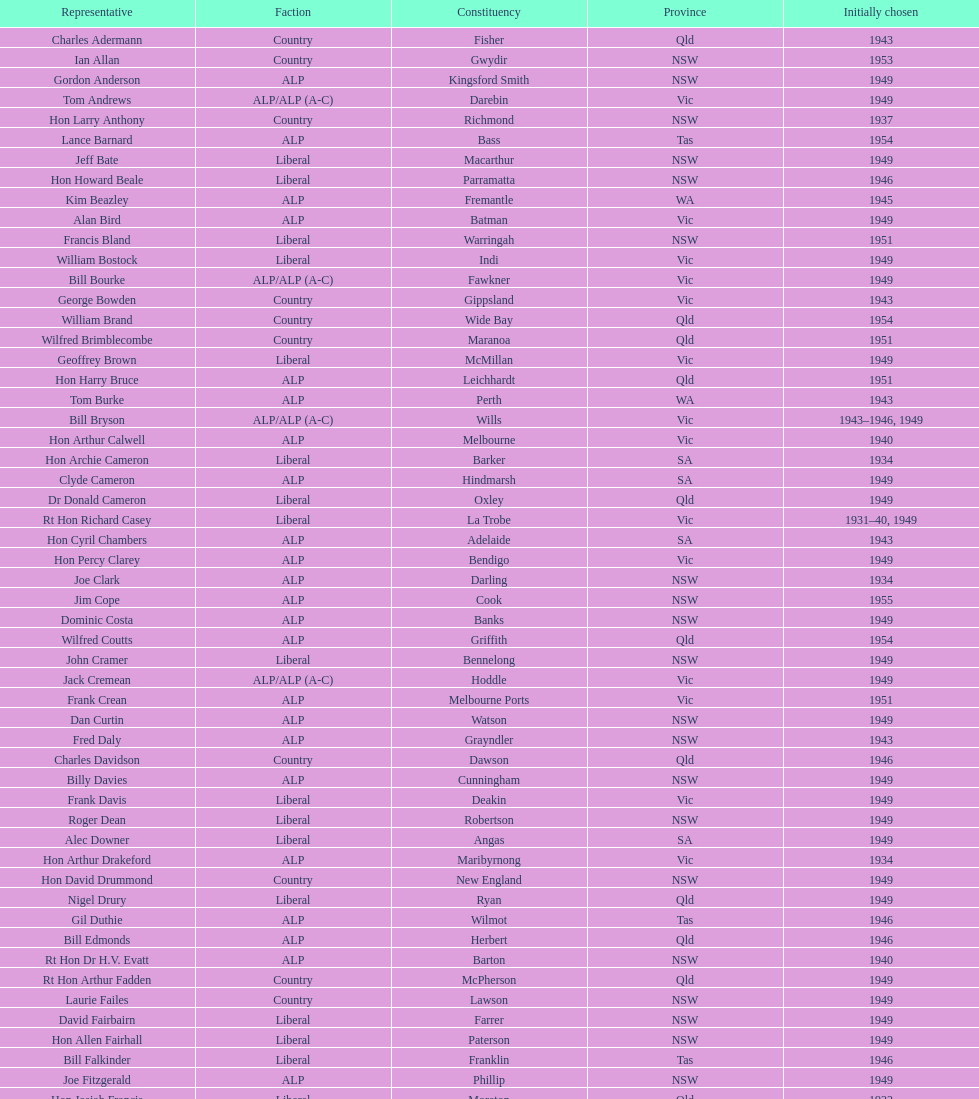Did tom burke run as country or alp party? ALP. 